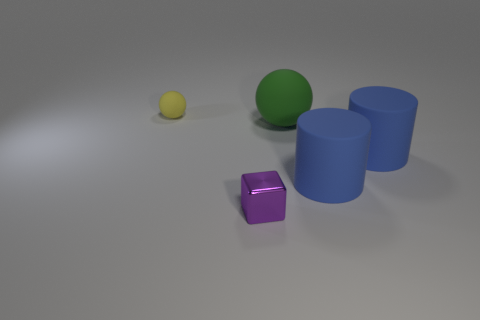There is a matte object that is the same size as the cube; what color is it?
Provide a short and direct response. Yellow. Is the shape of the large green object the same as the rubber thing that is left of the large green sphere?
Your answer should be compact. Yes. How many yellow spheres are in front of the matte sphere that is in front of the tiny object behind the tiny purple object?
Give a very brief answer. 0. There is a sphere that is in front of the matte ball that is behind the large green sphere; how big is it?
Give a very brief answer. Large. The green ball that is made of the same material as the tiny yellow thing is what size?
Your answer should be very brief. Large. The thing that is both to the left of the large green rubber object and in front of the tiny matte sphere has what shape?
Offer a very short reply. Cube. Are there the same number of large matte things in front of the purple metallic cube and green rubber spheres?
Your answer should be compact. No. How many objects are tiny blue cylinders or cubes that are in front of the small yellow matte object?
Provide a succinct answer. 1. Is there a tiny purple object of the same shape as the green thing?
Your answer should be compact. No. Is the number of yellow rubber objects in front of the shiny cube the same as the number of green things that are on the right side of the large green sphere?
Your answer should be compact. Yes. 